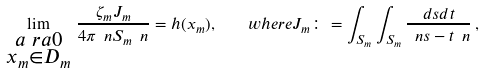<formula> <loc_0><loc_0><loc_500><loc_500>\lim _ { \substack { a \ r a 0 \\ x _ { m } \in D _ { m } } } \, \frac { \zeta _ { m } J _ { m } } { 4 \pi \ n S _ { m } \ n } = h ( x _ { m } ) , \quad w h e r e J _ { m } \colon = \int _ { S _ { m } } \int _ { S _ { m } } \frac { d s d t } { \ n s - t \ n } \, ,</formula> 